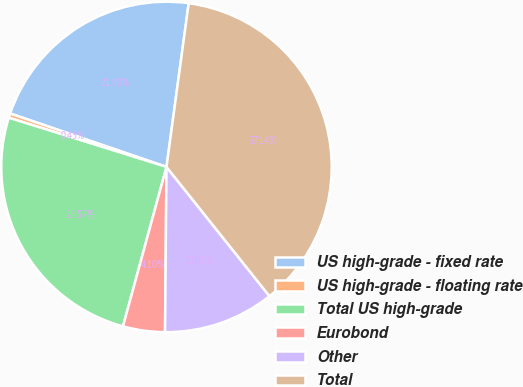Convert chart. <chart><loc_0><loc_0><loc_500><loc_500><pie_chart><fcel>US high-grade - fixed rate<fcel>US high-grade - floating rate<fcel>Total US high-grade<fcel>Eurobond<fcel>Other<fcel>Total<nl><fcel>21.9%<fcel>0.43%<fcel>25.57%<fcel>4.1%<fcel>10.85%<fcel>37.14%<nl></chart> 